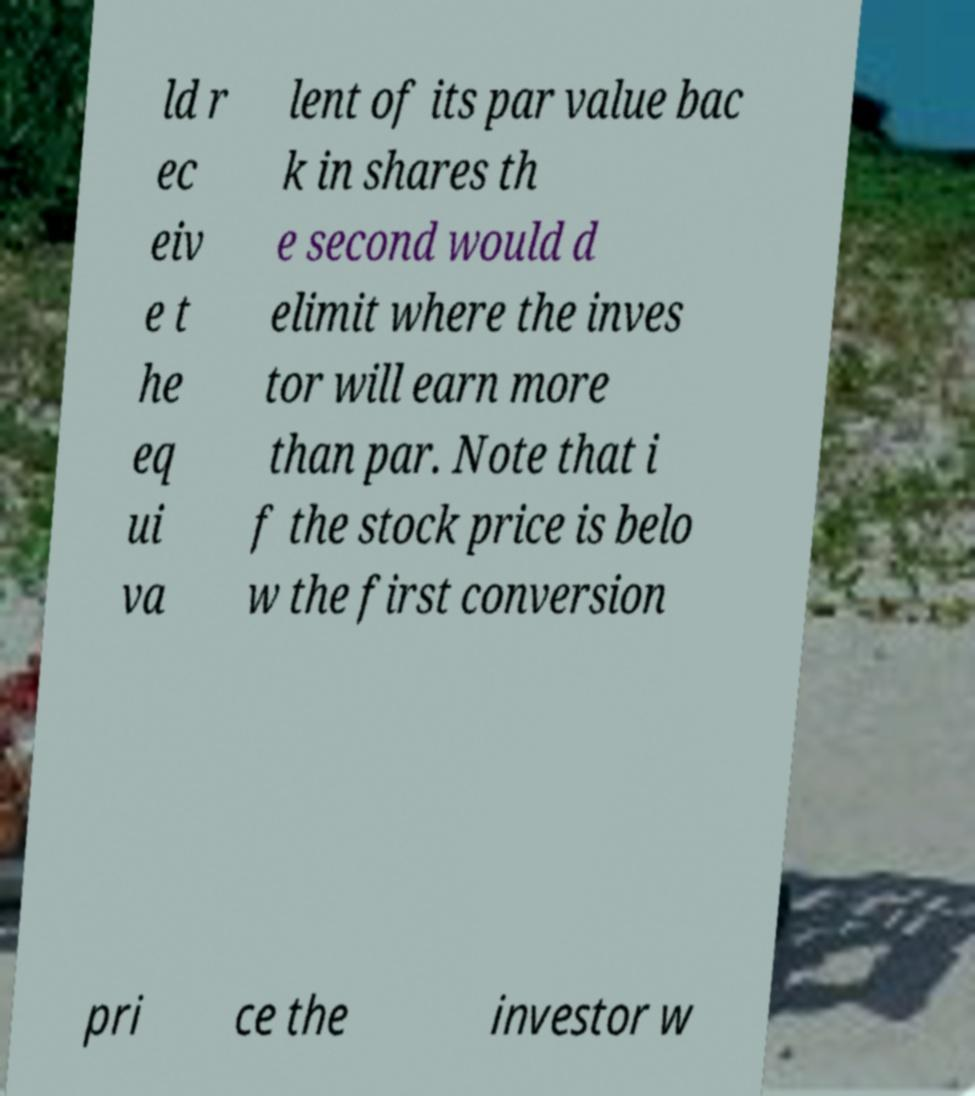I need the written content from this picture converted into text. Can you do that? ld r ec eiv e t he eq ui va lent of its par value bac k in shares th e second would d elimit where the inves tor will earn more than par. Note that i f the stock price is belo w the first conversion pri ce the investor w 